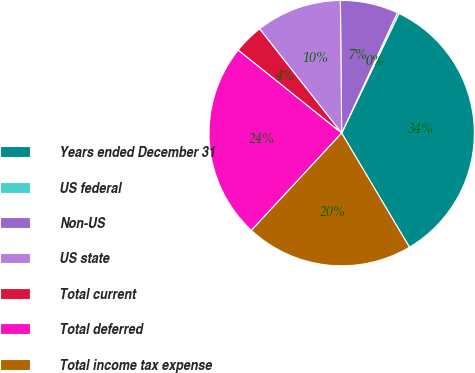Convert chart. <chart><loc_0><loc_0><loc_500><loc_500><pie_chart><fcel>Years ended December 31<fcel>US federal<fcel>Non-US<fcel>US state<fcel>Total current<fcel>Total deferred<fcel>Total income tax expense<nl><fcel>34.35%<fcel>0.22%<fcel>7.05%<fcel>10.46%<fcel>3.63%<fcel>23.85%<fcel>20.44%<nl></chart> 